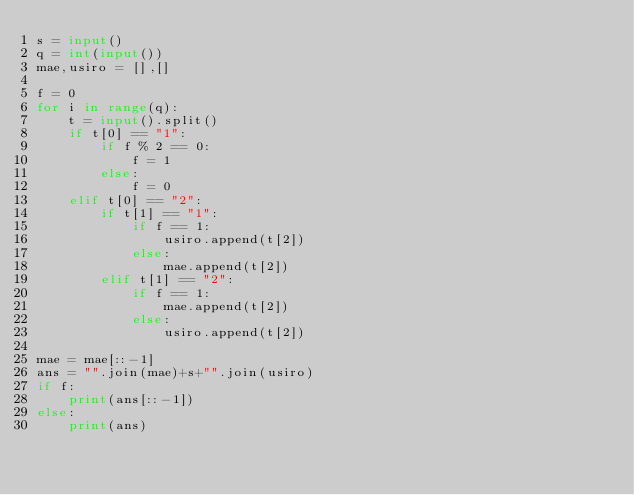<code> <loc_0><loc_0><loc_500><loc_500><_Python_>s = input()
q = int(input())
mae,usiro = [],[]

f = 0
for i in range(q):
    t = input().split()
    if t[0] == "1":
        if f % 2 == 0:
            f = 1
        else:
            f = 0
    elif t[0] == "2":
        if t[1] == "1":
            if f == 1:
                usiro.append(t[2])
            else:
                mae.append(t[2])
        elif t[1] == "2":
            if f == 1:
                mae.append(t[2])
            else:
                usiro.append(t[2])

mae = mae[::-1]
ans = "".join(mae)+s+"".join(usiro)
if f:
    print(ans[::-1])
else:
    print(ans)
</code> 